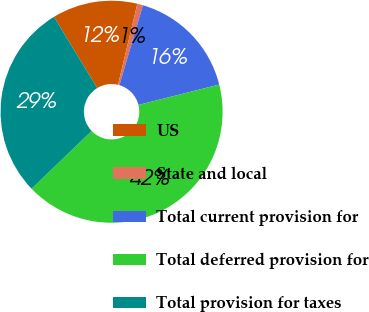Convert chart. <chart><loc_0><loc_0><loc_500><loc_500><pie_chart><fcel>US<fcel>State and local<fcel>Total current provision for<fcel>Total deferred provision for<fcel>Total provision for taxes<nl><fcel>12.41%<fcel>0.83%<fcel>16.5%<fcel>41.75%<fcel>28.51%<nl></chart> 